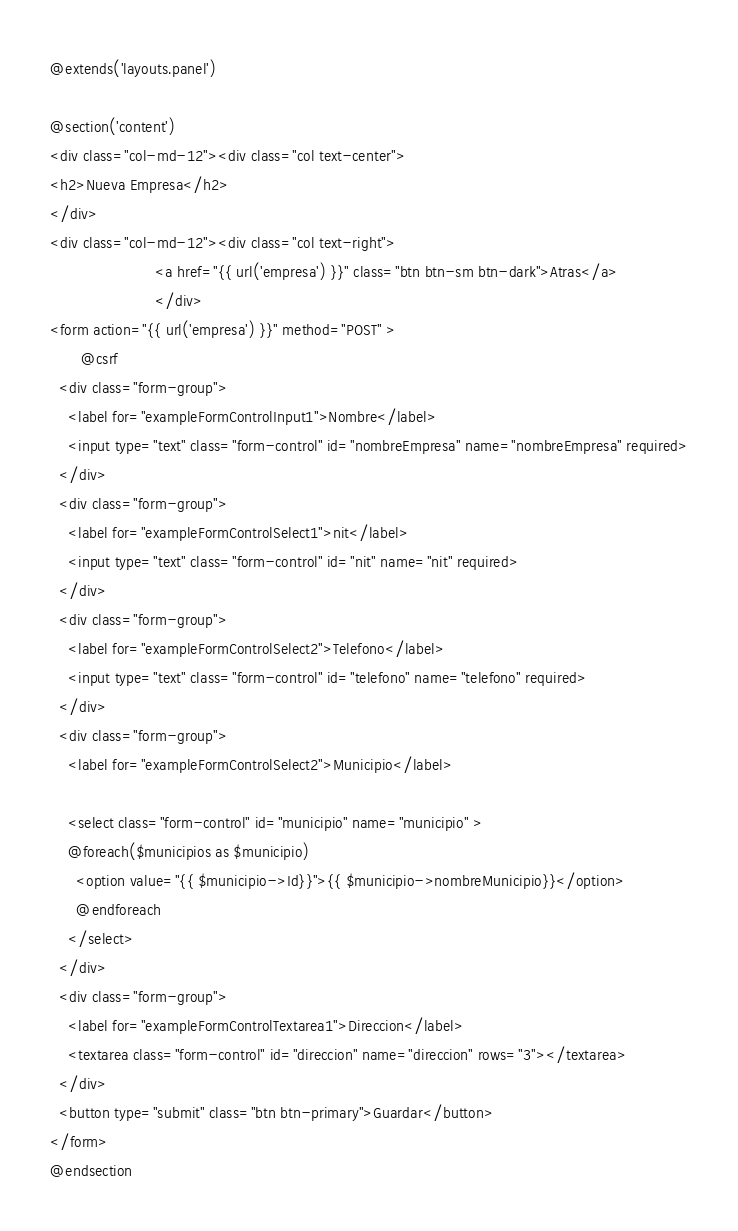<code> <loc_0><loc_0><loc_500><loc_500><_PHP_>@extends('layouts.panel')

@section('content')
<div class="col-md-12"><div class="col text-center">
<h2>Nueva Empresa</h2> 
</div>
<div class="col-md-12"><div class="col text-right">
                        <a href="{{ url('empresa') }}" class="btn btn-sm btn-dark">Atras</a>
                        </div>
<form action="{{ url('empresa') }}" method="POST" >
       @csrf
  <div class="form-group">
    <label for="exampleFormControlInput1">Nombre</label>
    <input type="text" class="form-control" id="nombreEmpresa" name="nombreEmpresa" required>
  </div>
  <div class="form-group">
    <label for="exampleFormControlSelect1">nit</label>
    <input type="text" class="form-control" id="nit" name="nit" required>
  </div>
  <div class="form-group">
    <label for="exampleFormControlSelect2">Telefono</label>
    <input type="text" class="form-control" id="telefono" name="telefono" required>
  </div>
  <div class="form-group">
    <label for="exampleFormControlSelect2">Municipio</label>
    
    <select class="form-control" id="municipio" name="municipio" >
    @foreach($municipios as $municipio)
      <option value="{{ $municipio->Id}}">{{ $municipio->nombreMunicipio}}</option>
      @endforeach
    </select>
  </div>
  <div class="form-group">
    <label for="exampleFormControlTextarea1">Direccion</label>
    <textarea class="form-control" id="direccion" name="direccion" rows="3"></textarea>
  </div>
  <button type="submit" class="btn btn-primary">Guardar</button>
</form>
@endsection
</code> 